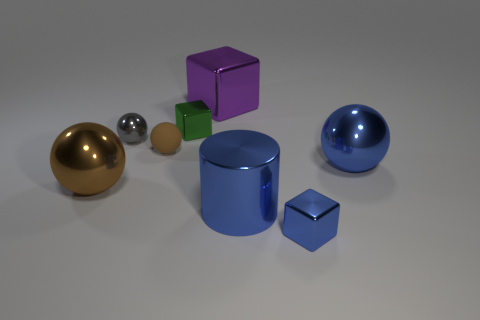What number of brown matte spheres are there?
Your answer should be very brief. 1. There is a small metallic thing that is left of the tiny shiny block behind the small blue metal object; what is its shape?
Give a very brief answer. Sphere. How many big purple metallic blocks are on the right side of the blue metal ball?
Keep it short and to the point. 0. Are the gray thing and the big sphere that is left of the tiny brown thing made of the same material?
Your answer should be compact. Yes. Is there a cyan rubber ball that has the same size as the brown metal thing?
Your answer should be very brief. No. Are there the same number of tiny green objects that are on the left side of the green cube and small gray spheres?
Offer a very short reply. No. The green metal object has what size?
Keep it short and to the point. Small. What number of spheres are on the right side of the rubber thing on the left side of the small blue shiny thing?
Keep it short and to the point. 1. The shiny object that is both behind the gray metal sphere and in front of the purple metallic object has what shape?
Your answer should be compact. Cube. What number of large metallic cubes have the same color as the big metal cylinder?
Your response must be concise. 0. 